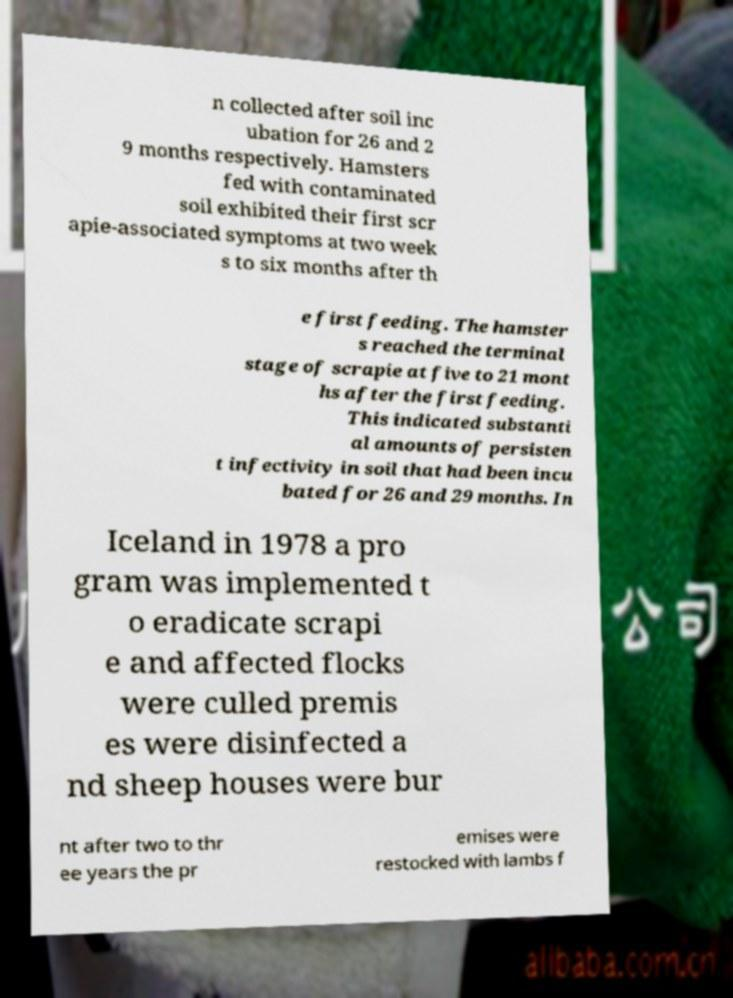There's text embedded in this image that I need extracted. Can you transcribe it verbatim? n collected after soil inc ubation for 26 and 2 9 months respectively. Hamsters fed with contaminated soil exhibited their first scr apie-associated symptoms at two week s to six months after th e first feeding. The hamster s reached the terminal stage of scrapie at five to 21 mont hs after the first feeding. This indicated substanti al amounts of persisten t infectivity in soil that had been incu bated for 26 and 29 months. In Iceland in 1978 a pro gram was implemented t o eradicate scrapi e and affected flocks were culled premis es were disinfected a nd sheep houses were bur nt after two to thr ee years the pr emises were restocked with lambs f 